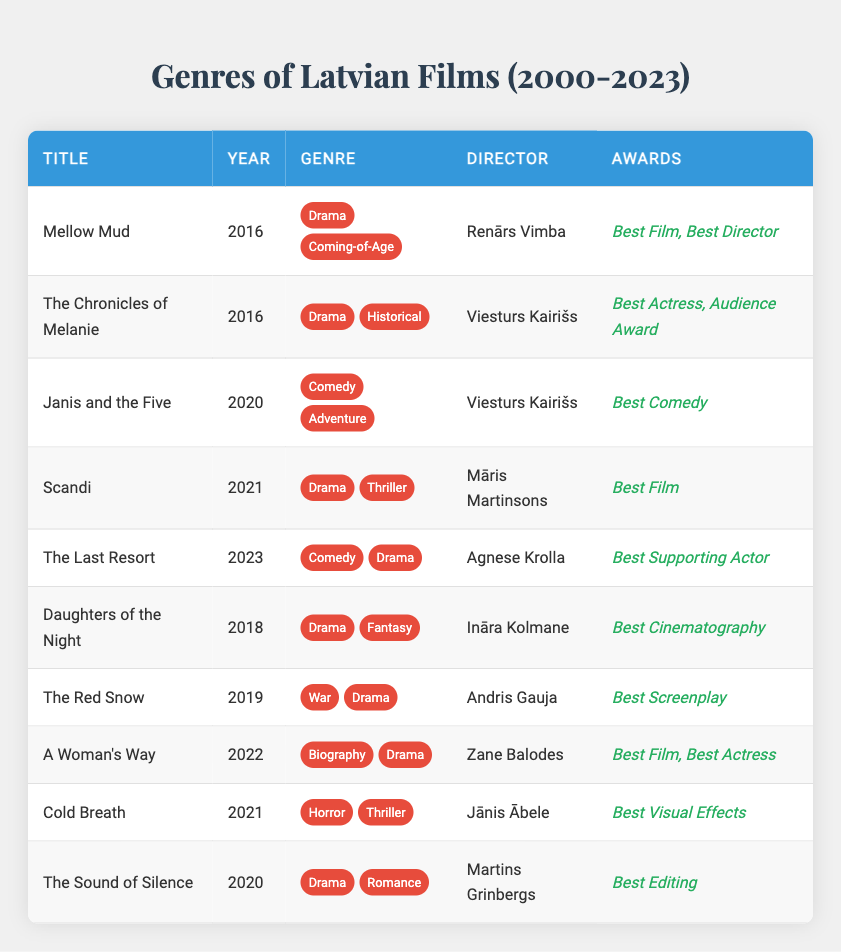What Latvian film genres are represented in 2021? The films produced in 2021 are "Scandi" (Drama, Thriller) and "Cold Breath" (Horror, Thriller). This shows that both Drama and Thriller are common genres for that year.
Answer: Drama, Thriller, Horror How many comedy films were released between 2000 and 2023? The films classified under the Comedy genre are "Janis and the Five" (2020), "The Last Resort" (2023), and these count up to 2.
Answer: 3 Which film won the Best Film award in 2016? The film "Mellow Mud," directed by Renārs Vimba, won the Best Film award in 2016.
Answer: Mellow Mud Is there any film that includes the genre "Fantasy"? Yes, "Daughters of the Night," released in 2018, is a film that includes the Fantasy genre along with Drama.
Answer: Yes What is the total number of Drama films produced in 2020? The only film listed for 2020 is "The Sound of Silence," which is a Drama. Therefore, the total is 1.
Answer: 1 Which director has worked on the most films from the table? Viesturs Kairišs has directed two films: "The Chronicles of Melanie" (2016) and "Janis and the Five" (2020), making him the most prolific director in this dataset.
Answer: Viesturs Kairišs How many different genres are found in the film "The Last Resort"? "The Last Resort" falls into two genres: Comedy and Drama, indicating a blend of both comedic and dramatic elements.
Answer: 2 In what year did the film directed by Māris Martinsons release? The film "Scandi," directed by Māris Martinsons, was released in 2021.
Answer: 2021 Which film directed by Zane Balodes received awards? "A Woman's Way," directed by Zane Balodes, received the awards for Best Film and Best Actress.
Answer: A Woman's Way Are there any films produced in 2019 that won awards? Yes, "The Red Snow," which was produced in 2019, won the award for Best Screenplay.
Answer: Yes What percentage of the films from 2000 to 2023 won an award? Out of the 10 listed films, 8 won at least one award. Therefore, the percentage of award-winning films is (8/10)*100 = 80%.
Answer: 80% 